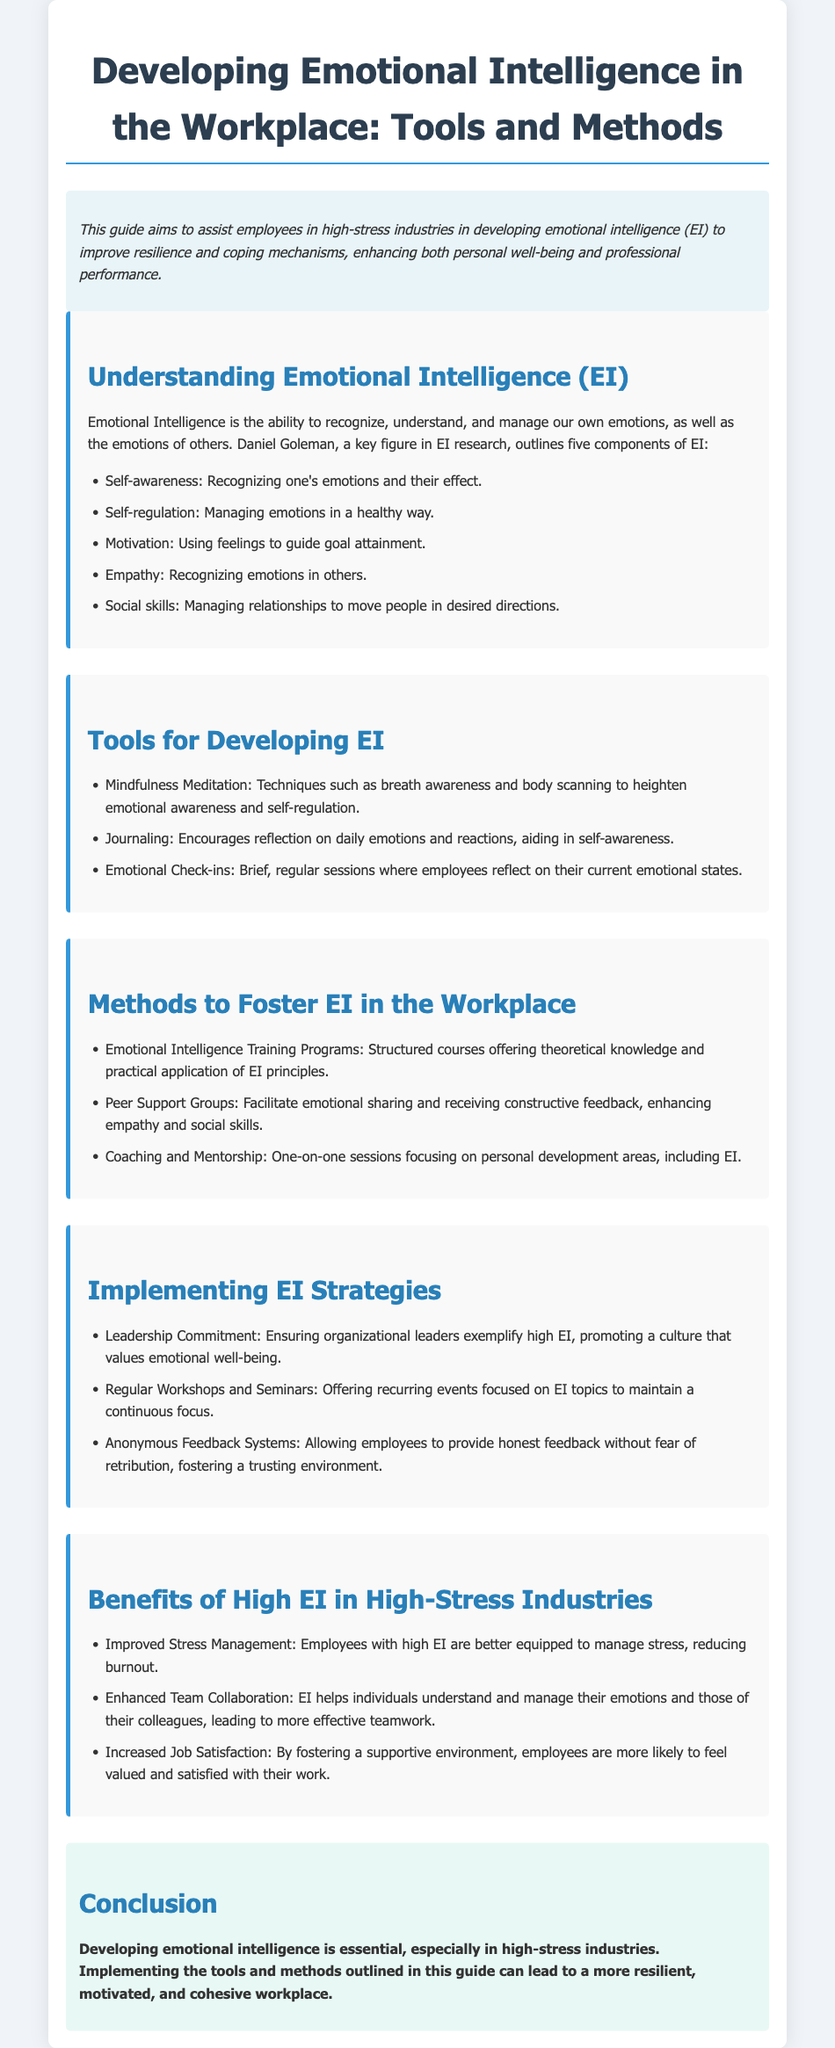What is the main focus of this guide? The main focus is to assist employees in high-stress industries in developing emotional intelligence to improve resilience and coping mechanisms.
Answer: Emotional intelligence development How many components of emotional intelligence are outlined? The document lists five components of emotional intelligence as defined by Daniel Goleman.
Answer: Five What is one tool mentioned for developing emotional intelligence? The guide provides several tools including mindfulness meditation, journaling, and emotional check-ins.
Answer: Mindfulness meditation What is a method to foster emotional intelligence in the workplace? The document includes emotional intelligence training programs, peer support groups, and coaching and mentorship as methods.
Answer: Emotional intelligence training programs Which component of emotional intelligence involves recognizing emotions in others? The guide describes empathy as the ability to recognize emotions in others.
Answer: Empathy What is listed as a benefit of high emotional intelligence in high-stress industries? The document states that improved stress management is a benefit of high emotional intelligence.
Answer: Improved stress management What strategy is suggested for implementing emotional intelligence? Leadership commitment is recommended to ensure organizational leaders promote a culture valuing emotional well-being.
Answer: Leadership commitment What year was this user guide published? The document does not specify a year of publication for the user guide.
Answer: Not specified 